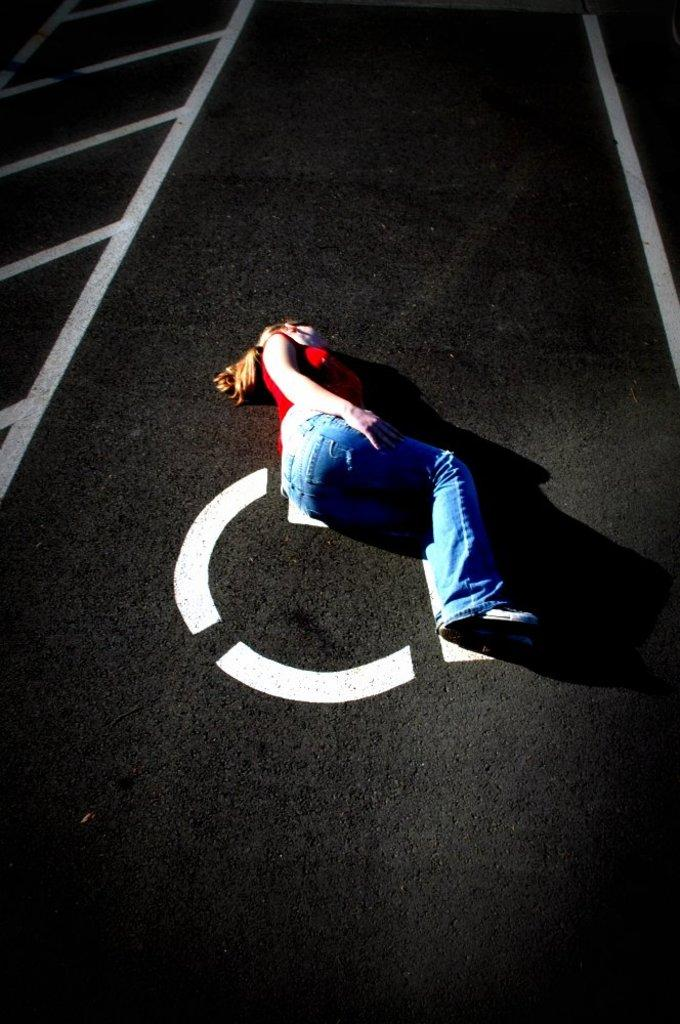What is the main subject of the image? There is a person lying on the floor in the image. Where is the person located in the image? The person is in the middle of the image. What can be seen on the floor in the image? There is white color paint on the floor. Is there a veil covering the person in the image? No, there is no veil present in the image. What type of lamp is being used by the person in the image? There is no lamp visible in the image; it only features a person lying on the floor with white color paint on the floor. 